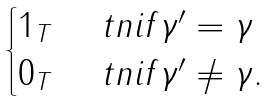Convert formula to latex. <formula><loc_0><loc_0><loc_500><loc_500>\begin{cases} 1 _ { T } & \ t n { i f } \gamma ^ { \prime } = \gamma \\ 0 _ { T } & \ t n { i f } \gamma ^ { \prime } \ne \gamma . \end{cases}</formula> 